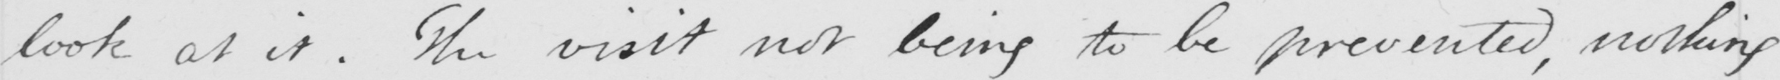Transcribe the text shown in this historical manuscript line. look at it . The visit not being to be prevented , nothing 